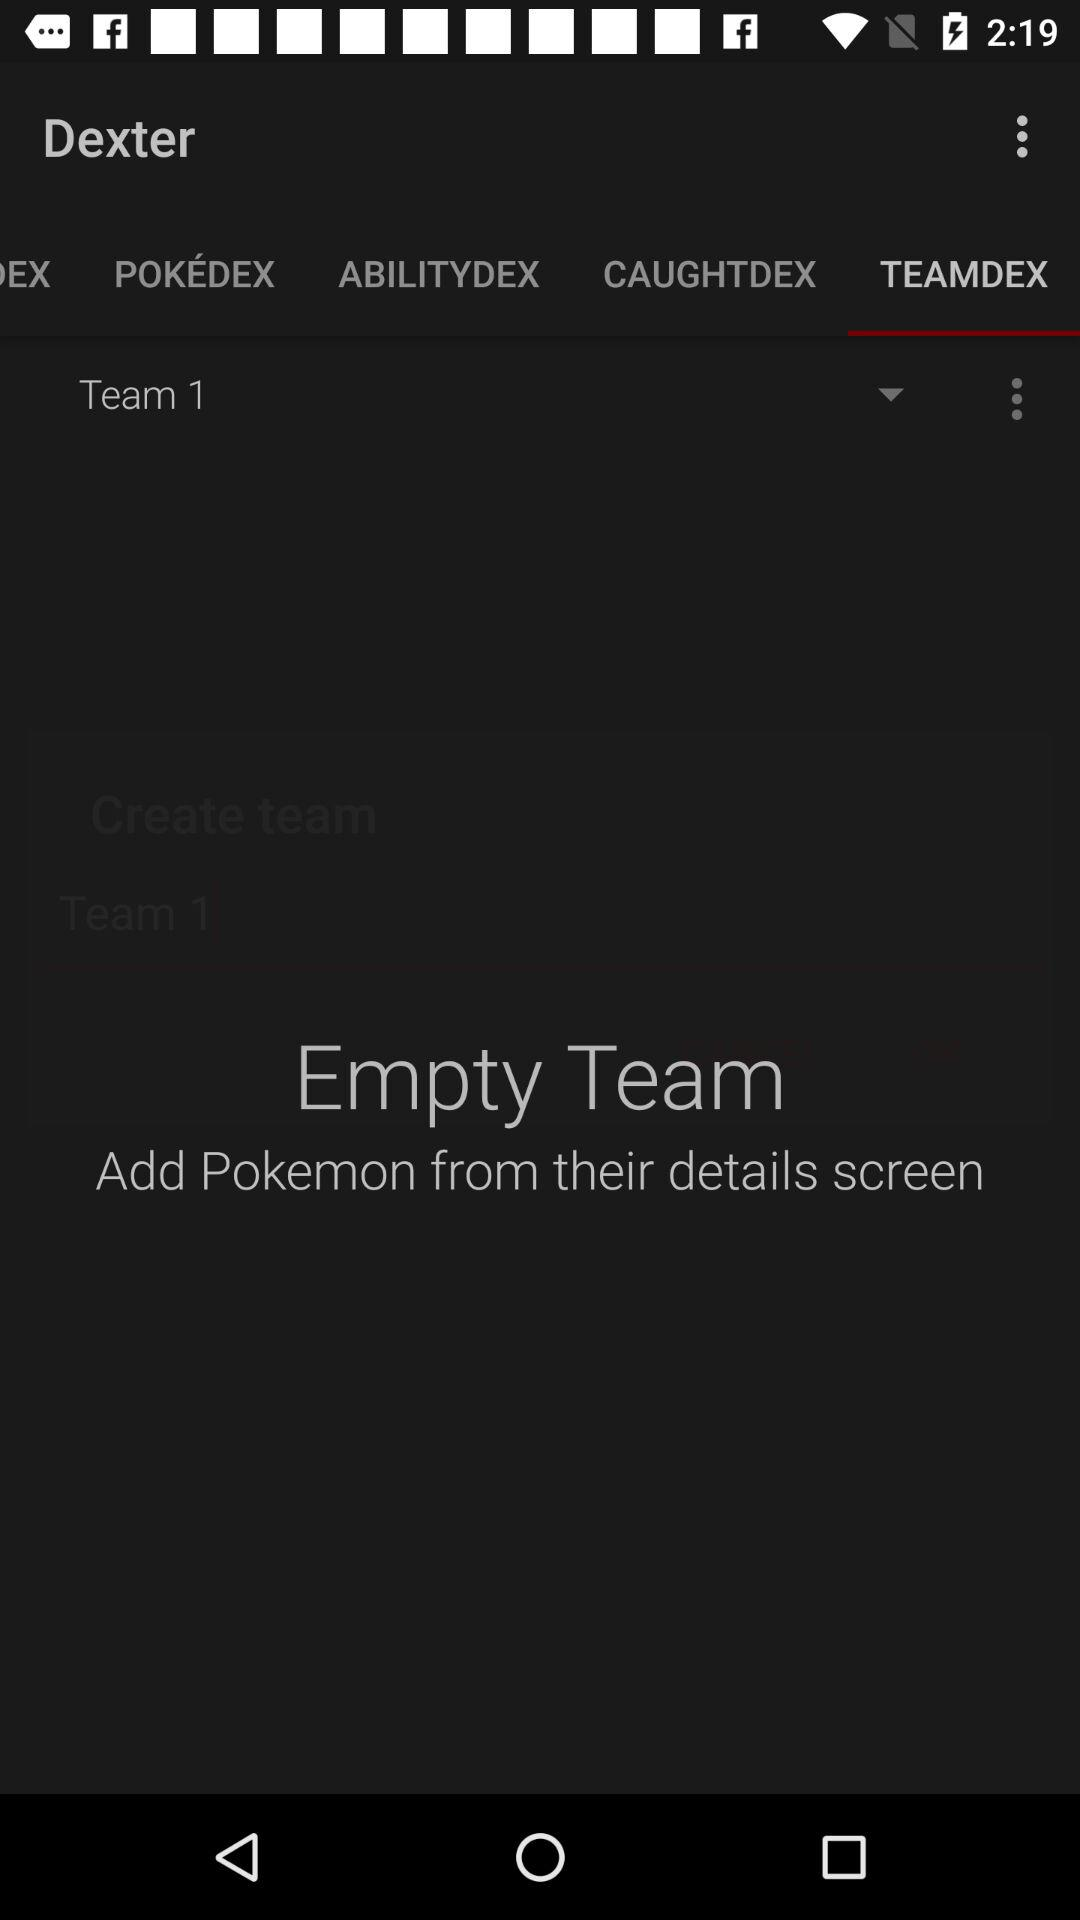Which tab is selected? The selected tab is "TEAMDEX". 